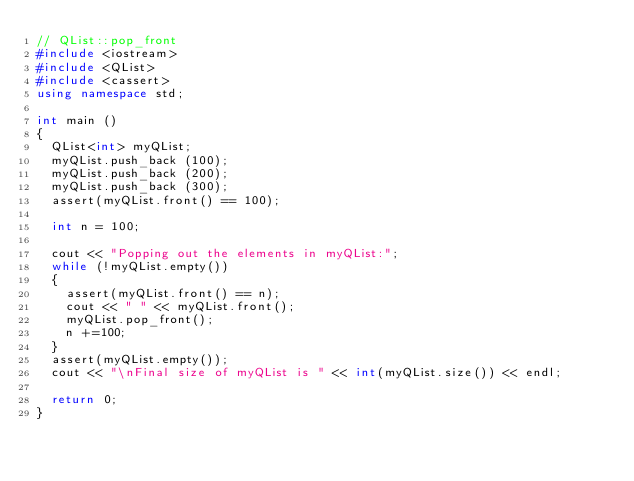<code> <loc_0><loc_0><loc_500><loc_500><_C++_>// QList::pop_front
#include <iostream>
#include <QList>
#include <cassert>
using namespace std;

int main ()
{
  QList<int> myQList;
  myQList.push_back (100);
  myQList.push_back (200);
  myQList.push_back (300);
  assert(myQList.front() == 100);
  
  int n = 100;
  
  cout << "Popping out the elements in myQList:";
  while (!myQList.empty())
  {
    assert(myQList.front() == n);
    cout << " " << myQList.front();
    myQList.pop_front();
    n +=100;
  }
  assert(myQList.empty());
  cout << "\nFinal size of myQList is " << int(myQList.size()) << endl;

  return 0;
}
</code> 